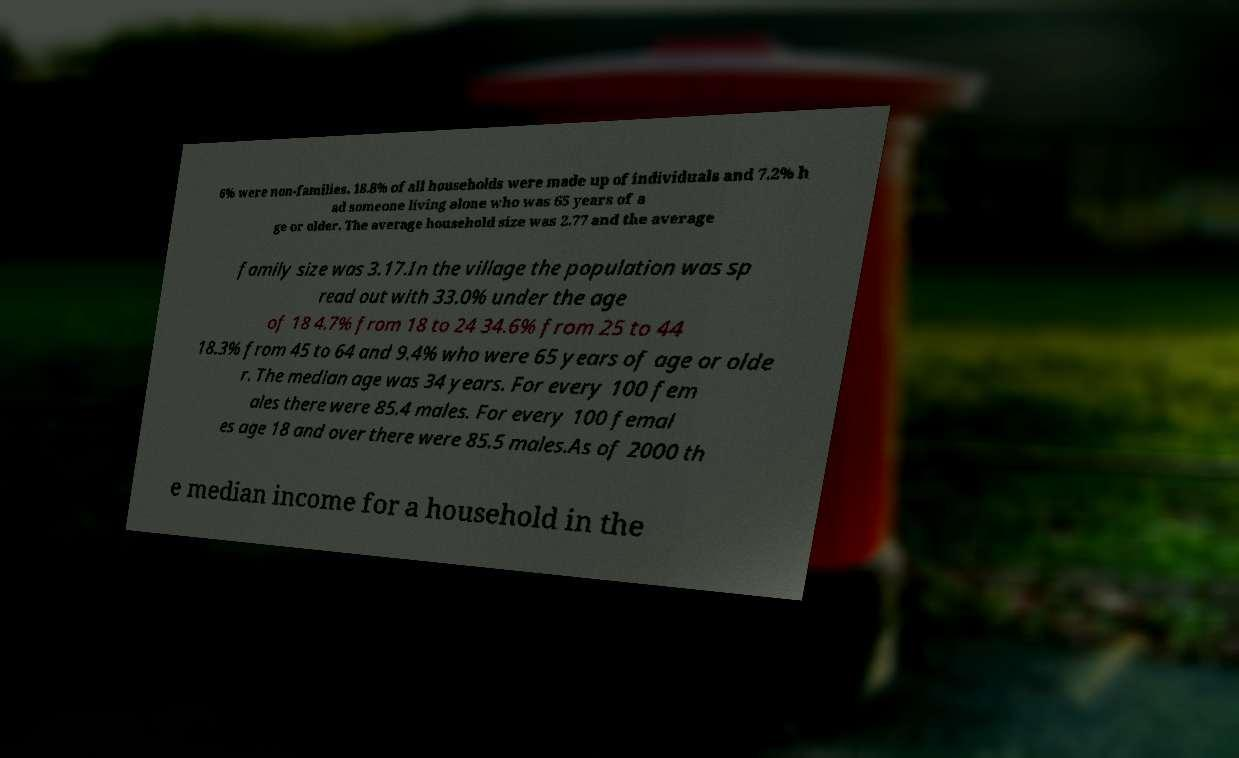Can you accurately transcribe the text from the provided image for me? 6% were non-families. 18.8% of all households were made up of individuals and 7.2% h ad someone living alone who was 65 years of a ge or older. The average household size was 2.77 and the average family size was 3.17.In the village the population was sp read out with 33.0% under the age of 18 4.7% from 18 to 24 34.6% from 25 to 44 18.3% from 45 to 64 and 9.4% who were 65 years of age or olde r. The median age was 34 years. For every 100 fem ales there were 85.4 males. For every 100 femal es age 18 and over there were 85.5 males.As of 2000 th e median income for a household in the 